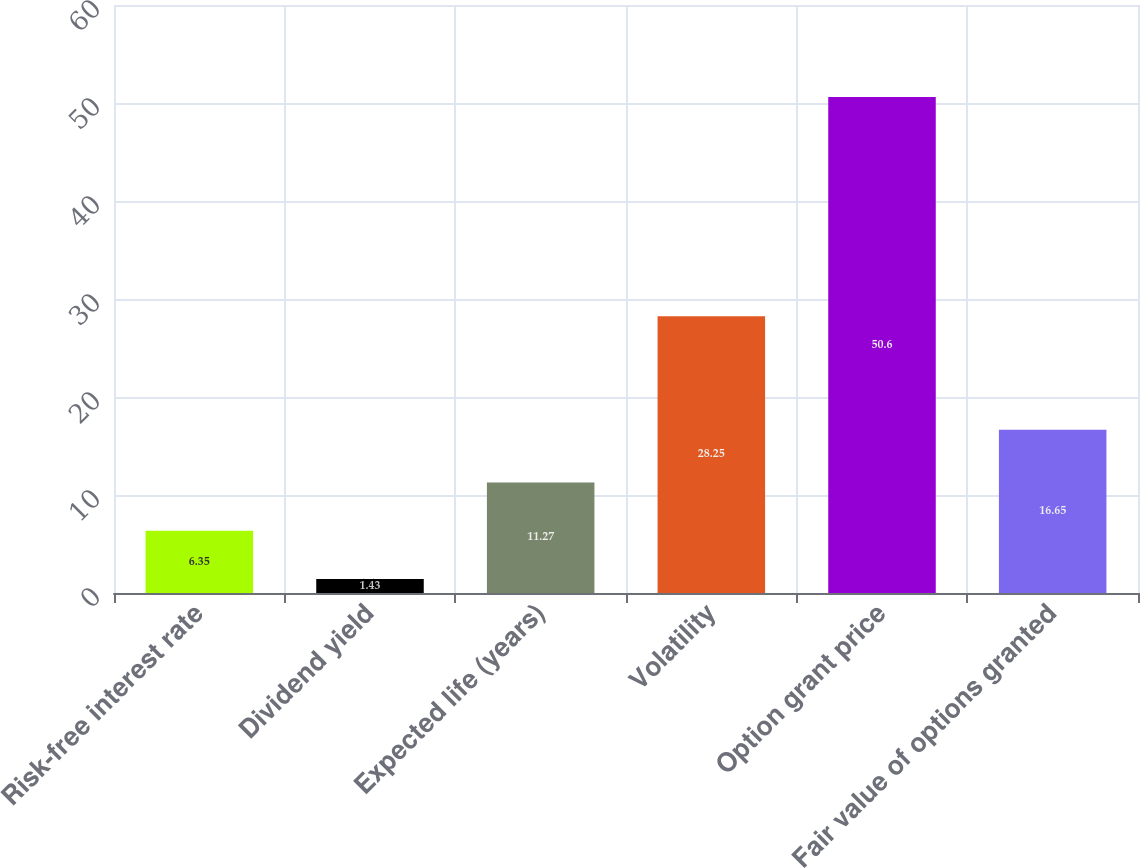<chart> <loc_0><loc_0><loc_500><loc_500><bar_chart><fcel>Risk-free interest rate<fcel>Dividend yield<fcel>Expected life (years)<fcel>Volatility<fcel>Option grant price<fcel>Fair value of options granted<nl><fcel>6.35<fcel>1.43<fcel>11.27<fcel>28.25<fcel>50.6<fcel>16.65<nl></chart> 